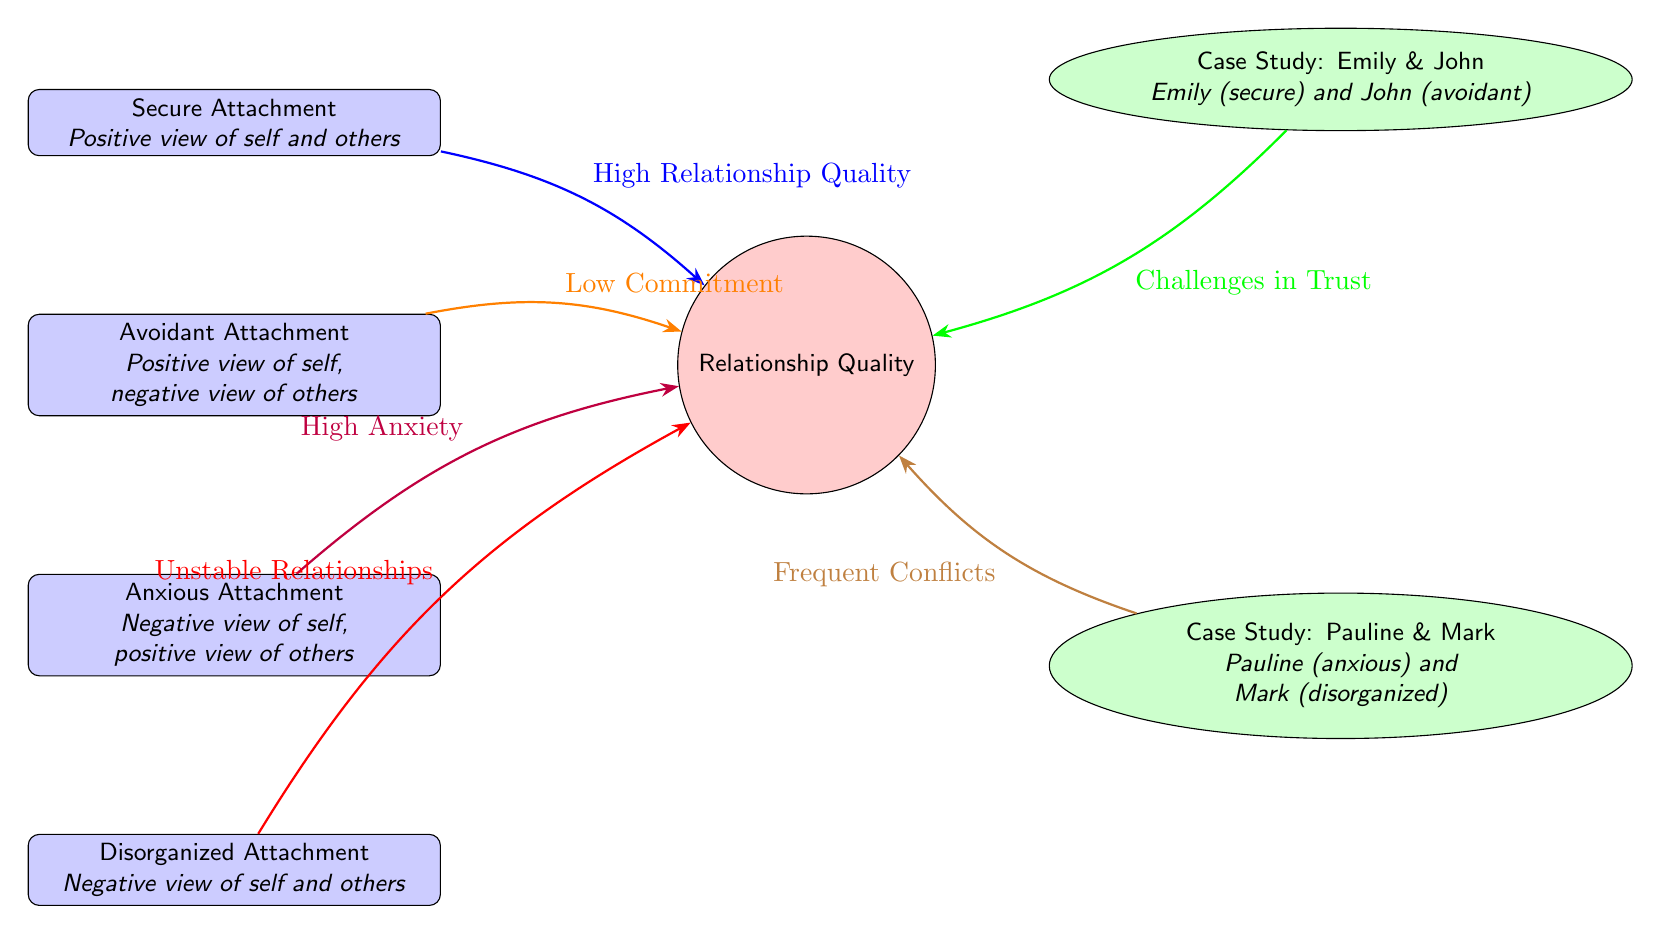What are the four attachment styles listed in the diagram? The diagram lists four attachment styles: Secure Attachment, Avoidant Attachment, Anxious Attachment, and Disorganized Attachment.
Answer: Secure Attachment, Avoidant Attachment, Anxious Attachment, Disorganized Attachment Which attachment style is associated with a positive view of self and others? The attachment style that features a positive view of self and others is Secure Attachment.
Answer: Secure Attachment What does the arrow from Anxious Attachment to Relationship Quality represent? The arrow from Anxious Attachment leads to the label "High Anxiety," indicating that this attachment style typically results in high anxiety within relationship quality.
Answer: High Anxiety How do Emily and John’s attachment styles affect their relationship? Emily has a Secure Attachment, and John has an Avoidant Attachment, which leads to challenges in trust within their relationship, as indicated by the arrow pointing to Relationship Quality.
Answer: Challenges in Trust What is the outcome for Pauline and Mark’s relationship according to their attachment styles? Pauline, who has Anxious Attachment, and Mark, who has Disorganized Attachment, result in frequent conflicts in their relationship quality, as evidenced by the arrow indicating this connection.
Answer: Frequent Conflicts What type of relationship quality is linked to Disorganized Attachment? Disorganized Attachment is linked to Unstable Relationships, as indicated by the arrow going from Disorganized Attachment to Relationship Quality.
Answer: Unstable Relationships How many case studies are presented in the diagram? There are two case studies presented in the diagram: one for Emily & John and another for Pauline & Mark.
Answer: Two Which attachment style has a negative view of self and a positive view of others? Anxious Attachment has a negative view of self and a positive view of others, as outlined in the description next to it.
Answer: Anxious Attachment What indicates a low commitment in a relationship? Avoidant Attachment is indicated to lead to Low Commitment in relationships, as shown by the arrow connecting this attachment style to Relationship Quality.
Answer: Low Commitment 